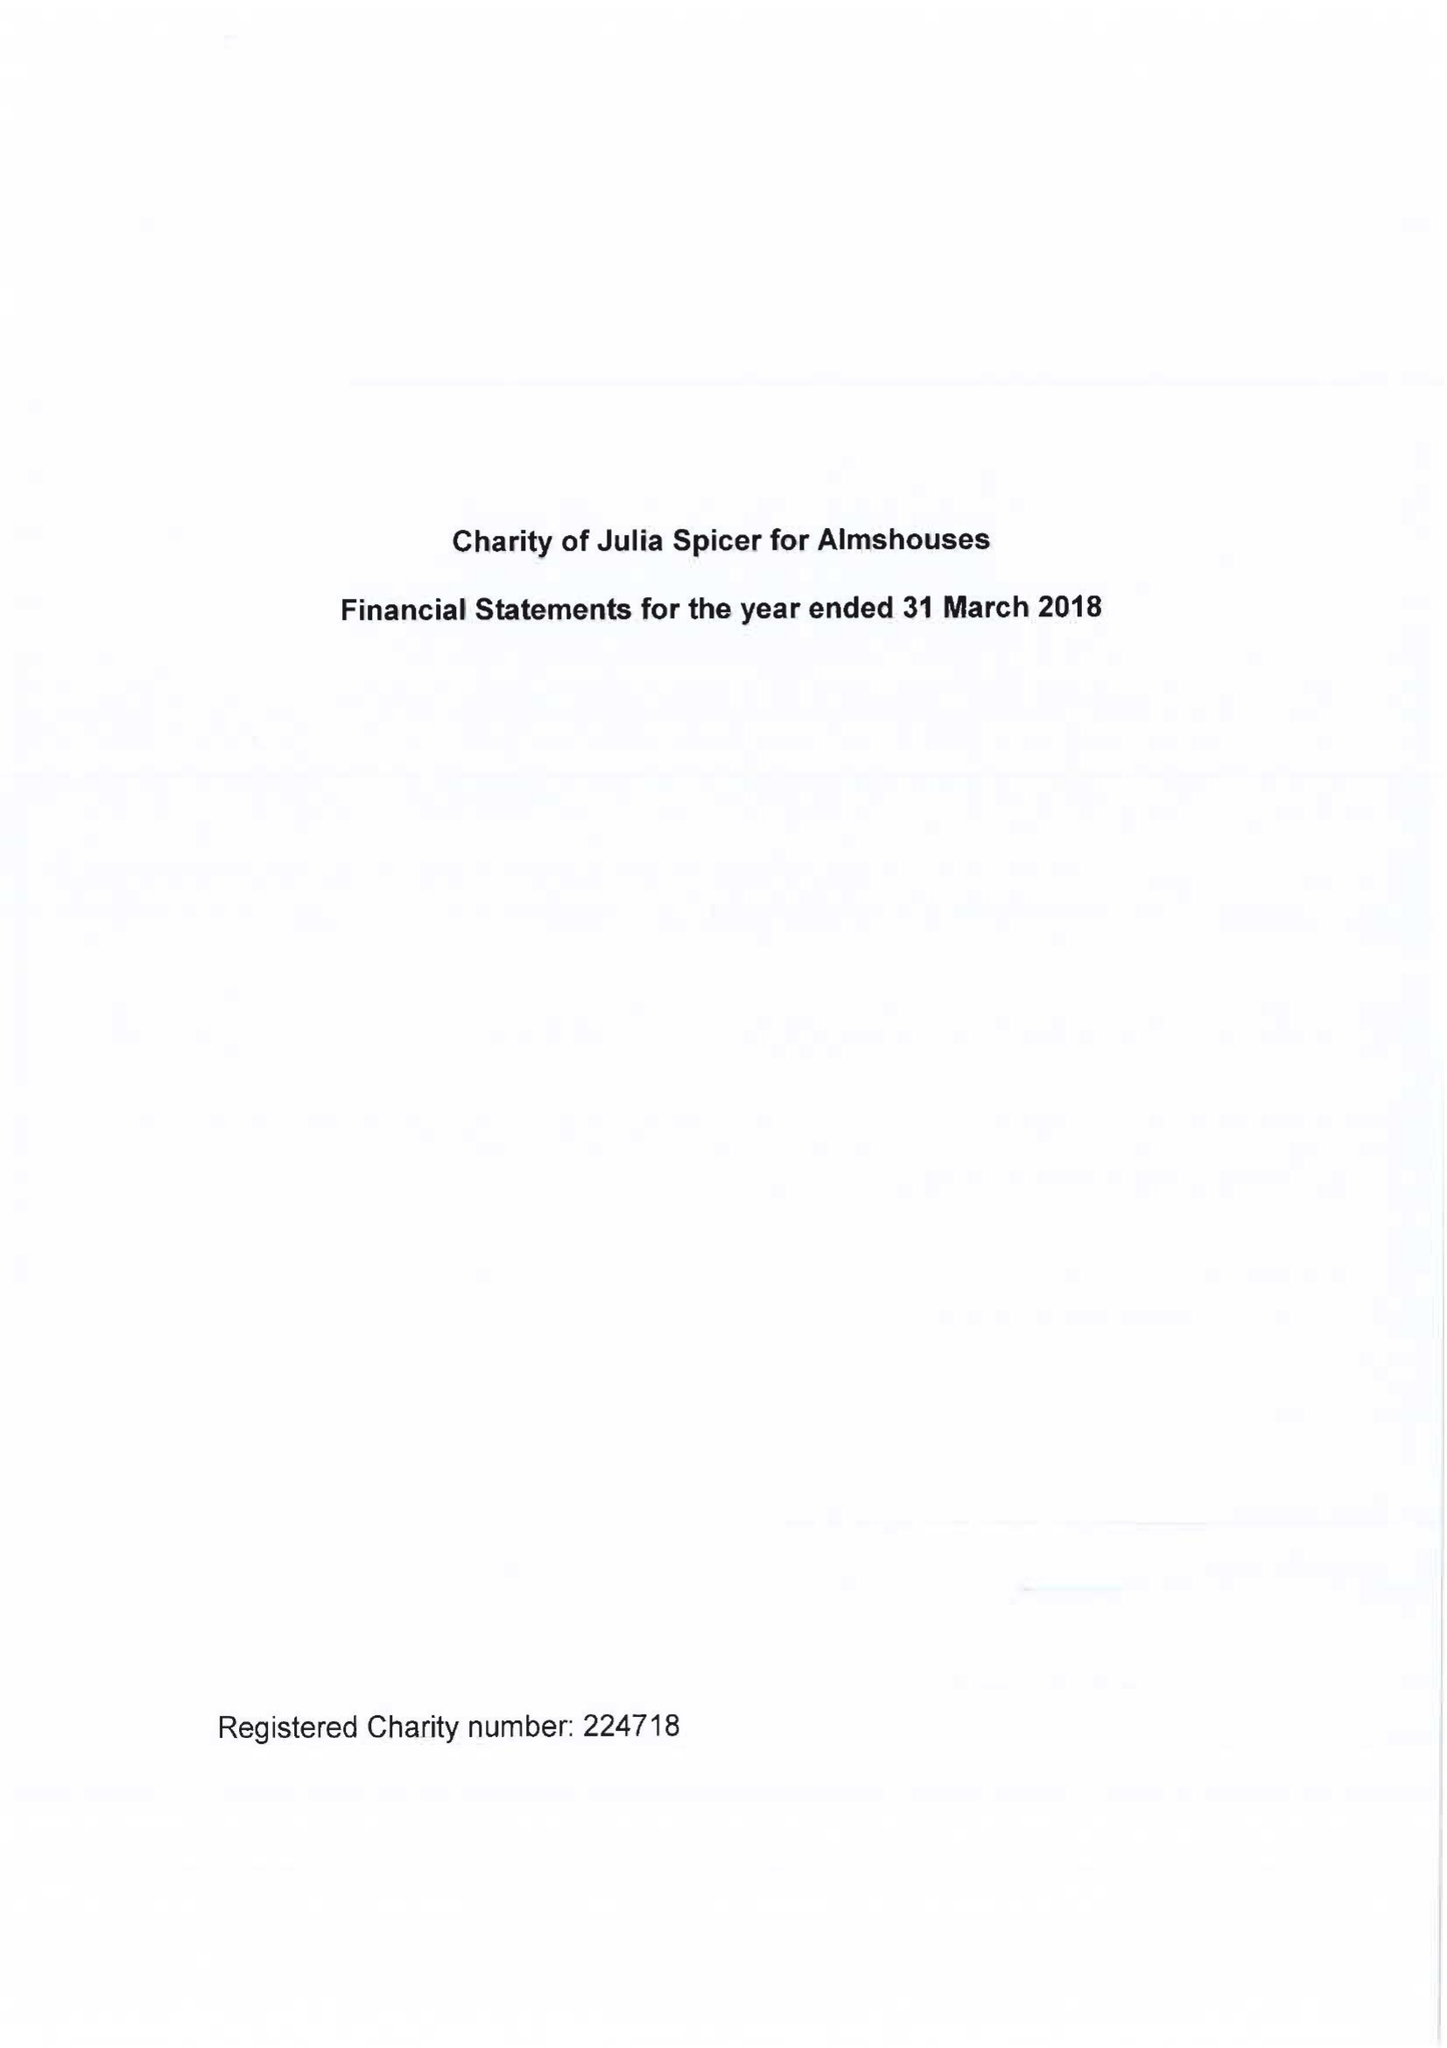What is the value for the charity_name?
Answer the question using a single word or phrase. Charity Of Julia Spicer For Almshouses 